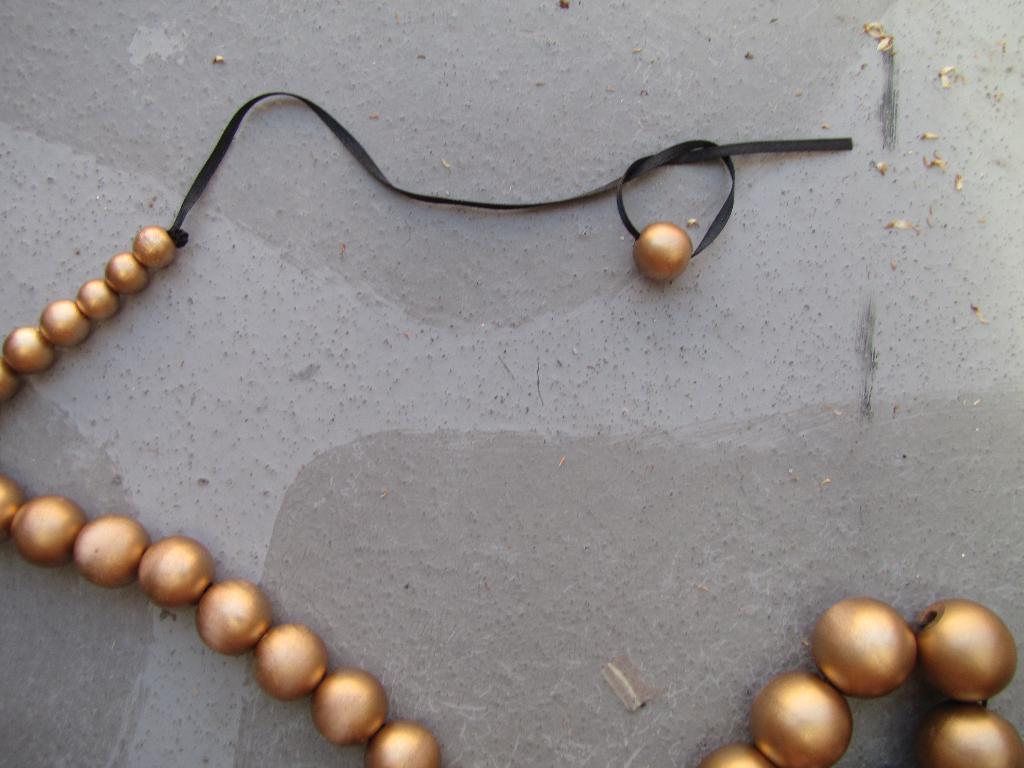Please provide a concise description of this image. In the middle of the image there is a chain with circular beads on the floor. 